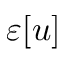Convert formula to latex. <formula><loc_0><loc_0><loc_500><loc_500>\varepsilon [ u ]</formula> 